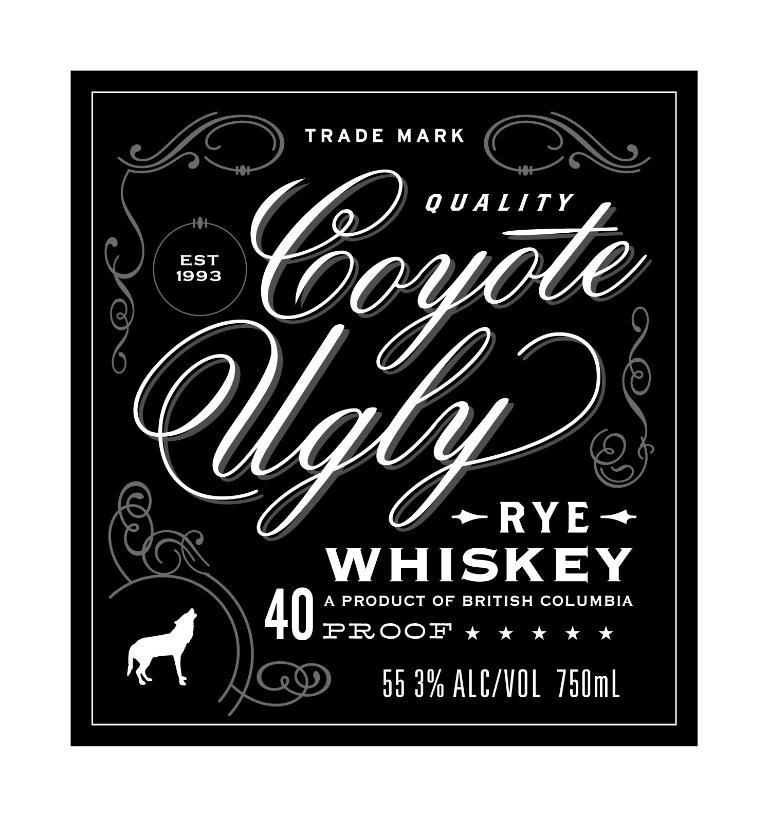<image>
Create a compact narrative representing the image presented. The label from a bottle of Coyote Ugly Rye whiskey which is 40 proof and comes from British Columbia. 